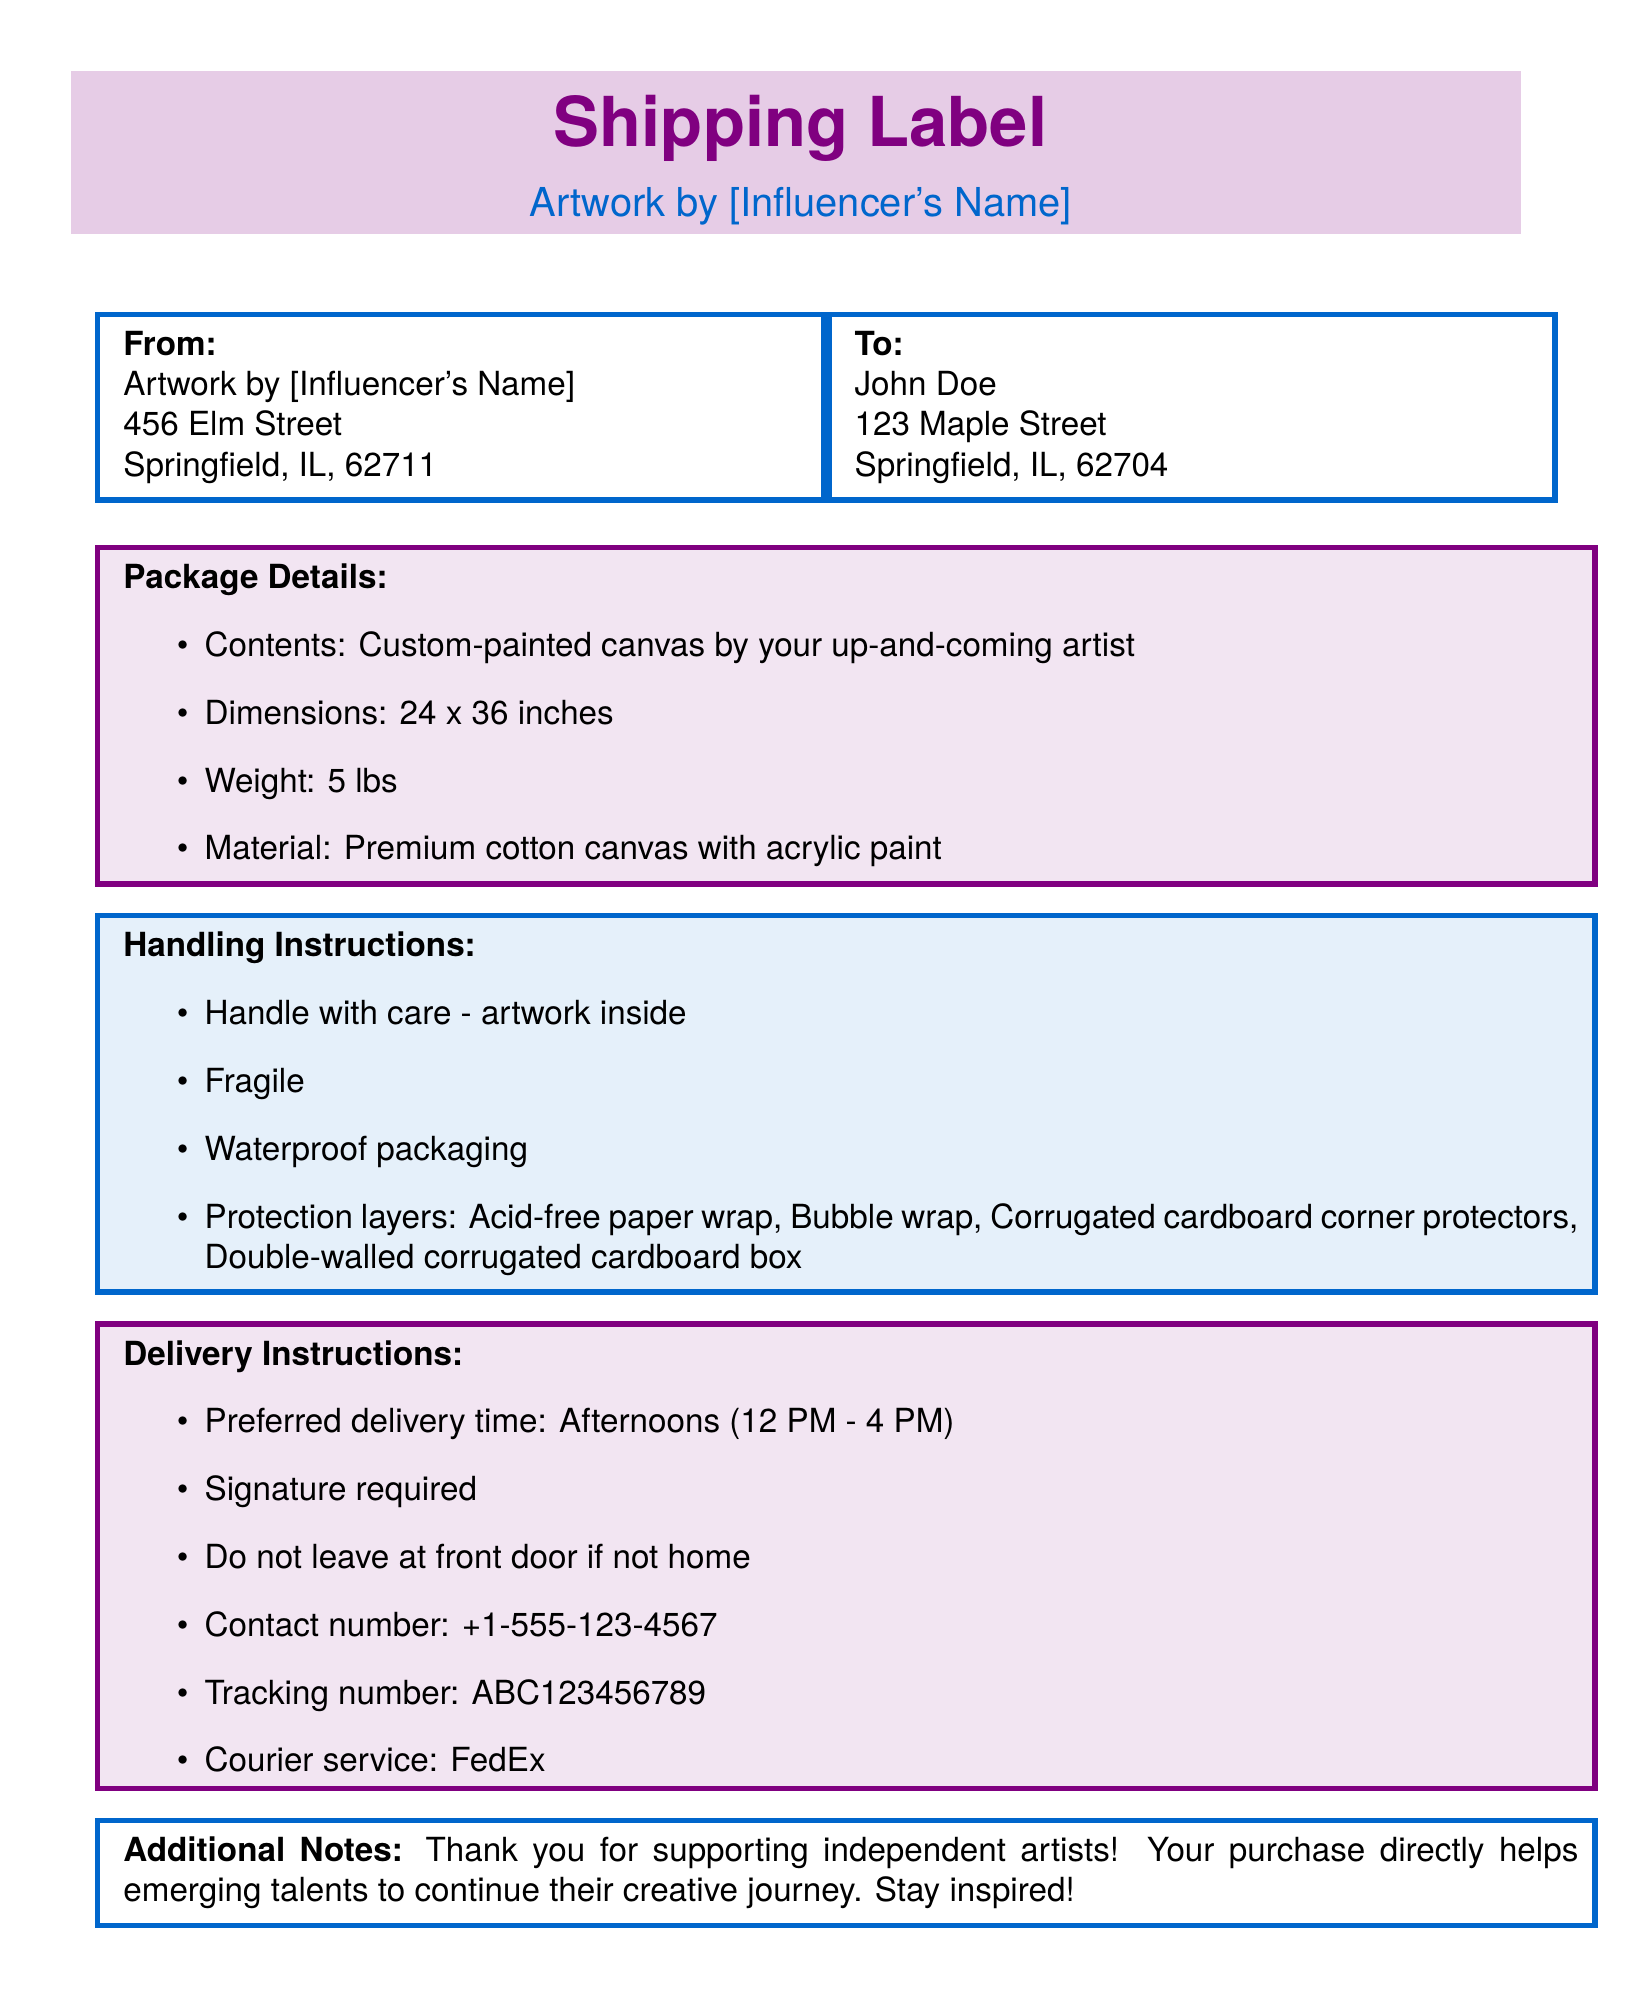What is the recipient's name? The recipient's name is listed in the "To" section of the shipping label.
Answer: John Doe What are the package dimensions? The dimensions of the package are specified in the "Package Details" section of the document.
Answer: 24 x 36 inches What type of paint is used on the canvas? The type of paint used is mentioned in the "Package Details" section.
Answer: Acrylic paint What is the weight of the package? The weight is provided in the "Package Details" section of the label.
Answer: 5 lbs What is the preferred delivery time? The preferred delivery time is mentioned in the "Delivery Instructions" section.
Answer: Afternoons (12 PM - 4 PM) Is a signature required upon delivery? This information is specified in the "Delivery Instructions" section of the document.
Answer: Yes What type of packaging is used for protection? The types of protective packaging are listed under "Handling Instructions."
Answer: Acid-free paper wrap, Bubble wrap, Corrugated cardboard corner protectors, Double-walled corrugated cardboard box Which courier service will deliver the package? The courier service is indicated in the "Delivery Instructions" section.
Answer: FedEx What is the contact number provided for delivery issues? The contact number is specified in the "Delivery Instructions" section.
Answer: +1-555-123-4567 